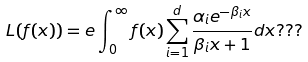Convert formula to latex. <formula><loc_0><loc_0><loc_500><loc_500>L ( f ( x ) ) = e \int _ { 0 } ^ { \infty } f ( x ) \sum _ { i = 1 } ^ { d } \frac { \alpha _ { i } e ^ { - \beta _ { i } x } } { \beta _ { i } x + 1 } d x ? ? ?</formula> 